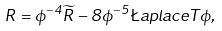<formula> <loc_0><loc_0><loc_500><loc_500>R = \phi ^ { - 4 } \widetilde { R } - 8 \phi ^ { - 5 } \L a p l a c e T \phi ,</formula> 